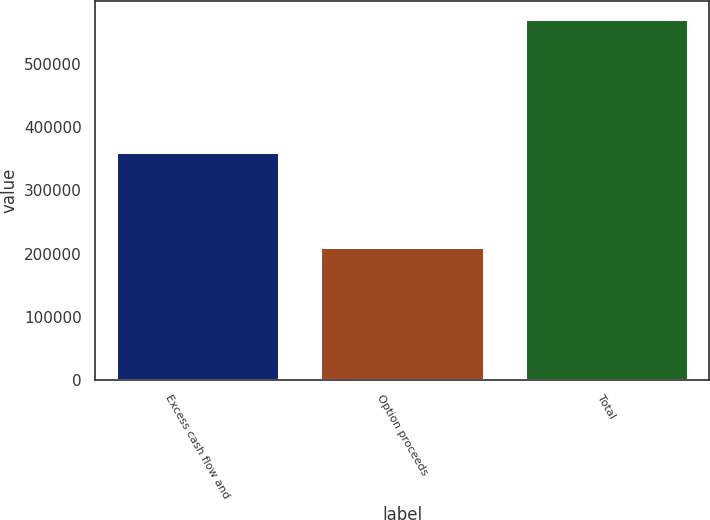<chart> <loc_0><loc_0><loc_500><loc_500><bar_chart><fcel>Excess cash flow and<fcel>Option proceeds<fcel>Total<nl><fcel>360490<fcel>209675<fcel>570165<nl></chart> 